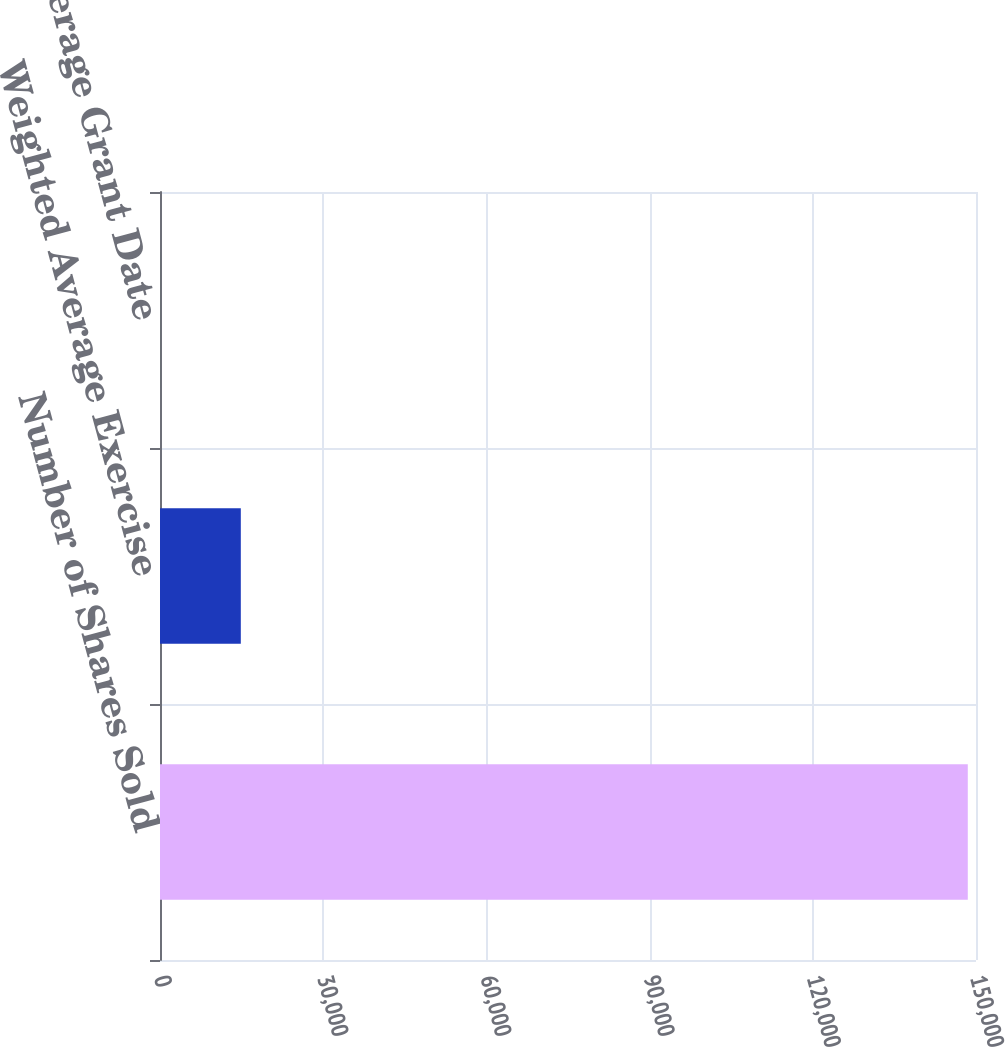<chart> <loc_0><loc_0><loc_500><loc_500><bar_chart><fcel>Number of Shares Sold<fcel>Weighted Average Exercise<fcel>Weighted Average Grant Date<nl><fcel>148490<fcel>14854.1<fcel>5.72<nl></chart> 